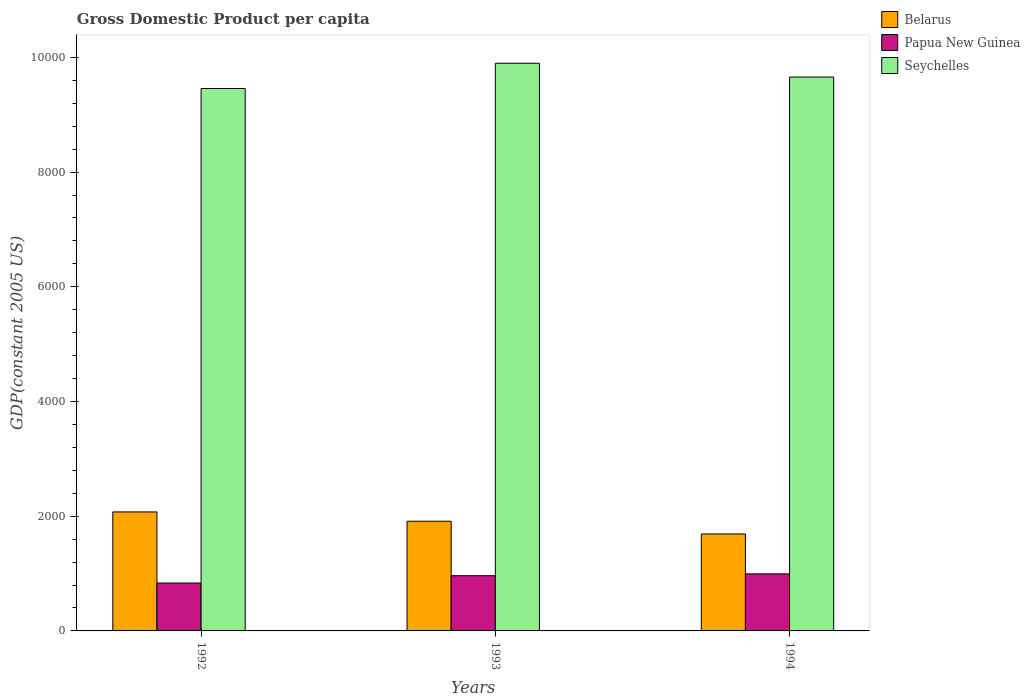How many groups of bars are there?
Provide a succinct answer. 3. Are the number of bars on each tick of the X-axis equal?
Keep it short and to the point. Yes. What is the GDP per capita in Seychelles in 1992?
Provide a short and direct response. 9456.67. Across all years, what is the maximum GDP per capita in Papua New Guinea?
Provide a short and direct response. 994.42. Across all years, what is the minimum GDP per capita in Belarus?
Your answer should be compact. 1690.82. In which year was the GDP per capita in Belarus minimum?
Provide a succinct answer. 1994. What is the total GDP per capita in Seychelles in the graph?
Your answer should be compact. 2.90e+04. What is the difference between the GDP per capita in Belarus in 1993 and that in 1994?
Your answer should be very brief. 221.79. What is the difference between the GDP per capita in Seychelles in 1993 and the GDP per capita in Papua New Guinea in 1994?
Give a very brief answer. 8902.68. What is the average GDP per capita in Belarus per year?
Provide a short and direct response. 1892.68. In the year 1994, what is the difference between the GDP per capita in Seychelles and GDP per capita in Belarus?
Make the answer very short. 7965.99. What is the ratio of the GDP per capita in Seychelles in 1992 to that in 1993?
Your answer should be very brief. 0.96. Is the difference between the GDP per capita in Seychelles in 1992 and 1994 greater than the difference between the GDP per capita in Belarus in 1992 and 1994?
Offer a very short reply. No. What is the difference between the highest and the second highest GDP per capita in Papua New Guinea?
Your response must be concise. 31.59. What is the difference between the highest and the lowest GDP per capita in Seychelles?
Provide a short and direct response. 440.42. In how many years, is the GDP per capita in Papua New Guinea greater than the average GDP per capita in Papua New Guinea taken over all years?
Keep it short and to the point. 2. What does the 3rd bar from the left in 1993 represents?
Make the answer very short. Seychelles. What does the 1st bar from the right in 1992 represents?
Offer a terse response. Seychelles. What is the difference between two consecutive major ticks on the Y-axis?
Give a very brief answer. 2000. Does the graph contain any zero values?
Your answer should be very brief. No. Does the graph contain grids?
Keep it short and to the point. No. Where does the legend appear in the graph?
Offer a terse response. Top right. How many legend labels are there?
Provide a succinct answer. 3. What is the title of the graph?
Offer a terse response. Gross Domestic Product per capita. Does "Europe(developing only)" appear as one of the legend labels in the graph?
Keep it short and to the point. No. What is the label or title of the X-axis?
Provide a short and direct response. Years. What is the label or title of the Y-axis?
Ensure brevity in your answer.  GDP(constant 2005 US). What is the GDP(constant 2005 US) in Belarus in 1992?
Keep it short and to the point. 2074.59. What is the GDP(constant 2005 US) of Papua New Guinea in 1992?
Your response must be concise. 835.3. What is the GDP(constant 2005 US) of Seychelles in 1992?
Provide a short and direct response. 9456.67. What is the GDP(constant 2005 US) in Belarus in 1993?
Your response must be concise. 1912.62. What is the GDP(constant 2005 US) in Papua New Guinea in 1993?
Provide a succinct answer. 962.82. What is the GDP(constant 2005 US) of Seychelles in 1993?
Give a very brief answer. 9897.09. What is the GDP(constant 2005 US) of Belarus in 1994?
Offer a terse response. 1690.82. What is the GDP(constant 2005 US) of Papua New Guinea in 1994?
Your response must be concise. 994.42. What is the GDP(constant 2005 US) in Seychelles in 1994?
Keep it short and to the point. 9656.81. Across all years, what is the maximum GDP(constant 2005 US) of Belarus?
Keep it short and to the point. 2074.59. Across all years, what is the maximum GDP(constant 2005 US) in Papua New Guinea?
Your response must be concise. 994.42. Across all years, what is the maximum GDP(constant 2005 US) of Seychelles?
Your answer should be compact. 9897.09. Across all years, what is the minimum GDP(constant 2005 US) of Belarus?
Provide a succinct answer. 1690.82. Across all years, what is the minimum GDP(constant 2005 US) in Papua New Guinea?
Give a very brief answer. 835.3. Across all years, what is the minimum GDP(constant 2005 US) in Seychelles?
Your response must be concise. 9456.67. What is the total GDP(constant 2005 US) in Belarus in the graph?
Keep it short and to the point. 5678.04. What is the total GDP(constant 2005 US) in Papua New Guinea in the graph?
Give a very brief answer. 2792.54. What is the total GDP(constant 2005 US) in Seychelles in the graph?
Give a very brief answer. 2.90e+04. What is the difference between the GDP(constant 2005 US) of Belarus in 1992 and that in 1993?
Provide a succinct answer. 161.98. What is the difference between the GDP(constant 2005 US) in Papua New Guinea in 1992 and that in 1993?
Provide a succinct answer. -127.52. What is the difference between the GDP(constant 2005 US) of Seychelles in 1992 and that in 1993?
Offer a very short reply. -440.42. What is the difference between the GDP(constant 2005 US) of Belarus in 1992 and that in 1994?
Provide a succinct answer. 383.77. What is the difference between the GDP(constant 2005 US) of Papua New Guinea in 1992 and that in 1994?
Offer a very short reply. -159.11. What is the difference between the GDP(constant 2005 US) in Seychelles in 1992 and that in 1994?
Keep it short and to the point. -200.14. What is the difference between the GDP(constant 2005 US) of Belarus in 1993 and that in 1994?
Ensure brevity in your answer.  221.79. What is the difference between the GDP(constant 2005 US) in Papua New Guinea in 1993 and that in 1994?
Give a very brief answer. -31.59. What is the difference between the GDP(constant 2005 US) of Seychelles in 1993 and that in 1994?
Your response must be concise. 240.28. What is the difference between the GDP(constant 2005 US) of Belarus in 1992 and the GDP(constant 2005 US) of Papua New Guinea in 1993?
Offer a terse response. 1111.77. What is the difference between the GDP(constant 2005 US) in Belarus in 1992 and the GDP(constant 2005 US) in Seychelles in 1993?
Your answer should be very brief. -7822.5. What is the difference between the GDP(constant 2005 US) of Papua New Guinea in 1992 and the GDP(constant 2005 US) of Seychelles in 1993?
Provide a succinct answer. -9061.79. What is the difference between the GDP(constant 2005 US) of Belarus in 1992 and the GDP(constant 2005 US) of Papua New Guinea in 1994?
Give a very brief answer. 1080.18. What is the difference between the GDP(constant 2005 US) in Belarus in 1992 and the GDP(constant 2005 US) in Seychelles in 1994?
Your answer should be very brief. -7582.22. What is the difference between the GDP(constant 2005 US) of Papua New Guinea in 1992 and the GDP(constant 2005 US) of Seychelles in 1994?
Your answer should be compact. -8821.51. What is the difference between the GDP(constant 2005 US) of Belarus in 1993 and the GDP(constant 2005 US) of Papua New Guinea in 1994?
Your answer should be compact. 918.2. What is the difference between the GDP(constant 2005 US) of Belarus in 1993 and the GDP(constant 2005 US) of Seychelles in 1994?
Offer a terse response. -7744.2. What is the difference between the GDP(constant 2005 US) of Papua New Guinea in 1993 and the GDP(constant 2005 US) of Seychelles in 1994?
Provide a succinct answer. -8693.99. What is the average GDP(constant 2005 US) of Belarus per year?
Provide a succinct answer. 1892.68. What is the average GDP(constant 2005 US) of Papua New Guinea per year?
Give a very brief answer. 930.85. What is the average GDP(constant 2005 US) of Seychelles per year?
Your answer should be compact. 9670.19. In the year 1992, what is the difference between the GDP(constant 2005 US) of Belarus and GDP(constant 2005 US) of Papua New Guinea?
Your response must be concise. 1239.29. In the year 1992, what is the difference between the GDP(constant 2005 US) in Belarus and GDP(constant 2005 US) in Seychelles?
Offer a very short reply. -7382.08. In the year 1992, what is the difference between the GDP(constant 2005 US) of Papua New Guinea and GDP(constant 2005 US) of Seychelles?
Provide a succinct answer. -8621.37. In the year 1993, what is the difference between the GDP(constant 2005 US) in Belarus and GDP(constant 2005 US) in Papua New Guinea?
Your answer should be compact. 949.79. In the year 1993, what is the difference between the GDP(constant 2005 US) of Belarus and GDP(constant 2005 US) of Seychelles?
Give a very brief answer. -7984.48. In the year 1993, what is the difference between the GDP(constant 2005 US) of Papua New Guinea and GDP(constant 2005 US) of Seychelles?
Keep it short and to the point. -8934.27. In the year 1994, what is the difference between the GDP(constant 2005 US) in Belarus and GDP(constant 2005 US) in Papua New Guinea?
Make the answer very short. 696.41. In the year 1994, what is the difference between the GDP(constant 2005 US) in Belarus and GDP(constant 2005 US) in Seychelles?
Make the answer very short. -7965.99. In the year 1994, what is the difference between the GDP(constant 2005 US) of Papua New Guinea and GDP(constant 2005 US) of Seychelles?
Your response must be concise. -8662.4. What is the ratio of the GDP(constant 2005 US) in Belarus in 1992 to that in 1993?
Your answer should be very brief. 1.08. What is the ratio of the GDP(constant 2005 US) in Papua New Guinea in 1992 to that in 1993?
Offer a terse response. 0.87. What is the ratio of the GDP(constant 2005 US) in Seychelles in 1992 to that in 1993?
Keep it short and to the point. 0.96. What is the ratio of the GDP(constant 2005 US) in Belarus in 1992 to that in 1994?
Ensure brevity in your answer.  1.23. What is the ratio of the GDP(constant 2005 US) in Papua New Guinea in 1992 to that in 1994?
Your answer should be compact. 0.84. What is the ratio of the GDP(constant 2005 US) in Seychelles in 1992 to that in 1994?
Make the answer very short. 0.98. What is the ratio of the GDP(constant 2005 US) in Belarus in 1993 to that in 1994?
Provide a short and direct response. 1.13. What is the ratio of the GDP(constant 2005 US) in Papua New Guinea in 1993 to that in 1994?
Give a very brief answer. 0.97. What is the ratio of the GDP(constant 2005 US) in Seychelles in 1993 to that in 1994?
Provide a short and direct response. 1.02. What is the difference between the highest and the second highest GDP(constant 2005 US) of Belarus?
Ensure brevity in your answer.  161.98. What is the difference between the highest and the second highest GDP(constant 2005 US) of Papua New Guinea?
Your response must be concise. 31.59. What is the difference between the highest and the second highest GDP(constant 2005 US) in Seychelles?
Give a very brief answer. 240.28. What is the difference between the highest and the lowest GDP(constant 2005 US) in Belarus?
Make the answer very short. 383.77. What is the difference between the highest and the lowest GDP(constant 2005 US) in Papua New Guinea?
Offer a terse response. 159.11. What is the difference between the highest and the lowest GDP(constant 2005 US) in Seychelles?
Your response must be concise. 440.42. 